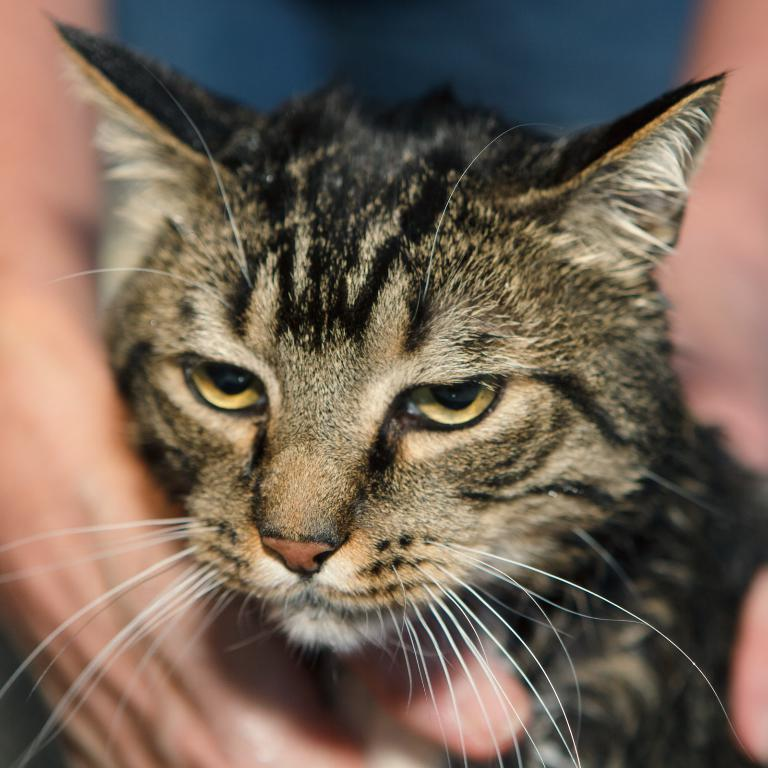What part of a person is visible in the image? There is a person's hand in the image. What is the person holding in the image? The person is holding a cat. What type of food is the monkey eating in the image? There is no monkey or food present in the image; it features a person's hand holding a cat. 